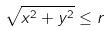<formula> <loc_0><loc_0><loc_500><loc_500>\sqrt { x ^ { 2 } + y ^ { 2 } } \leq r</formula> 